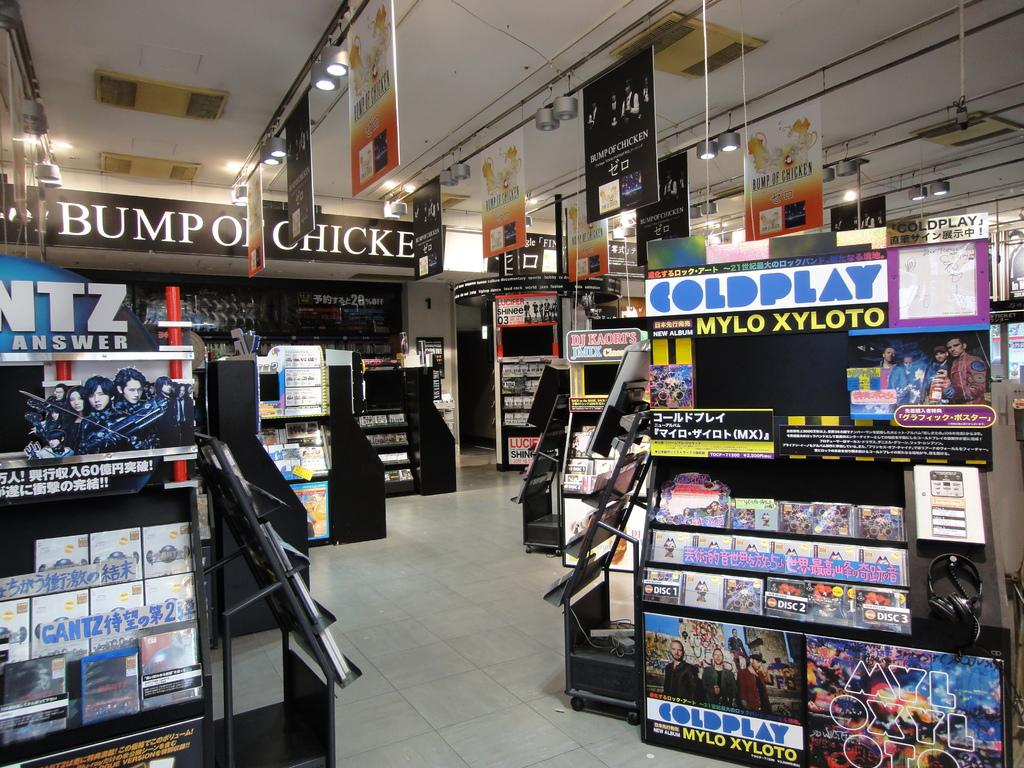<image>
Share a concise interpretation of the image provided. a building that has different stands in it with one of them labeled 'coldplay' 